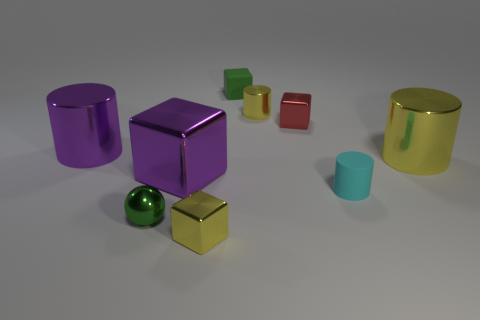Are there fewer small cubes than purple cylinders?
Ensure brevity in your answer.  No. What is the material of the yellow thing that is behind the cyan cylinder and to the left of the cyan cylinder?
Offer a very short reply. Metal. There is a big shiny cylinder that is right of the tiny red shiny object; are there any purple metal things that are in front of it?
Give a very brief answer. Yes. What number of big cylinders are the same color as the large block?
Make the answer very short. 1. There is a tiny sphere that is the same color as the rubber block; what is its material?
Make the answer very short. Metal. Does the red cube have the same material as the small green cube?
Your answer should be compact. No. Are there any tiny rubber objects to the left of the metal sphere?
Your answer should be compact. No. There is a yellow object that is behind the large thing on the right side of the tiny red cube; what is its material?
Your answer should be very brief. Metal. What size is the purple metal object that is the same shape as the large yellow object?
Provide a succinct answer. Large. Do the sphere and the small metal cylinder have the same color?
Give a very brief answer. No. 